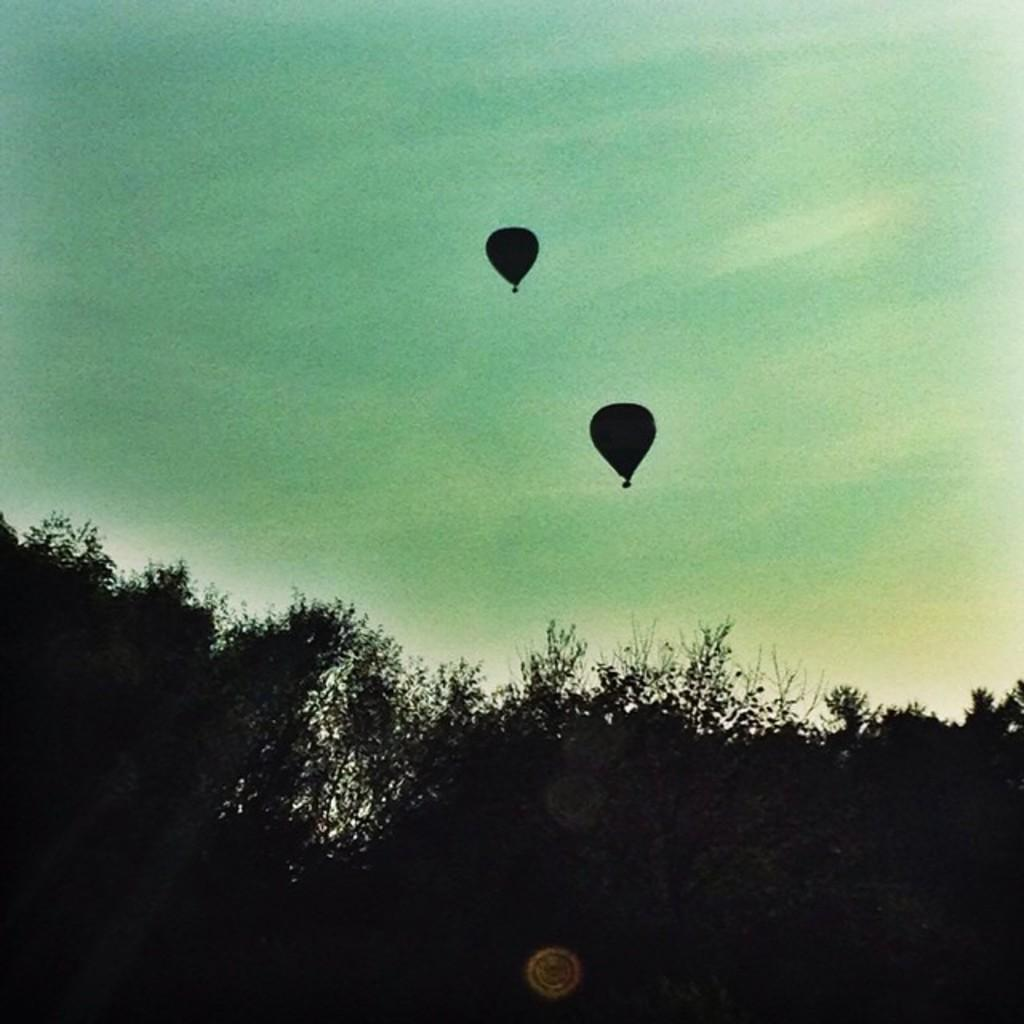What are the main subjects in the image? There are two hot air balloons in the image. What type of vegetation can be seen in the image? There are trees in the image. What is visible in the background of the image? The sky is visible in the image. What type of music can be heard coming from the hot air balloons in the image? There is no indication of music or any sounds coming from the hot air balloons in the image. 